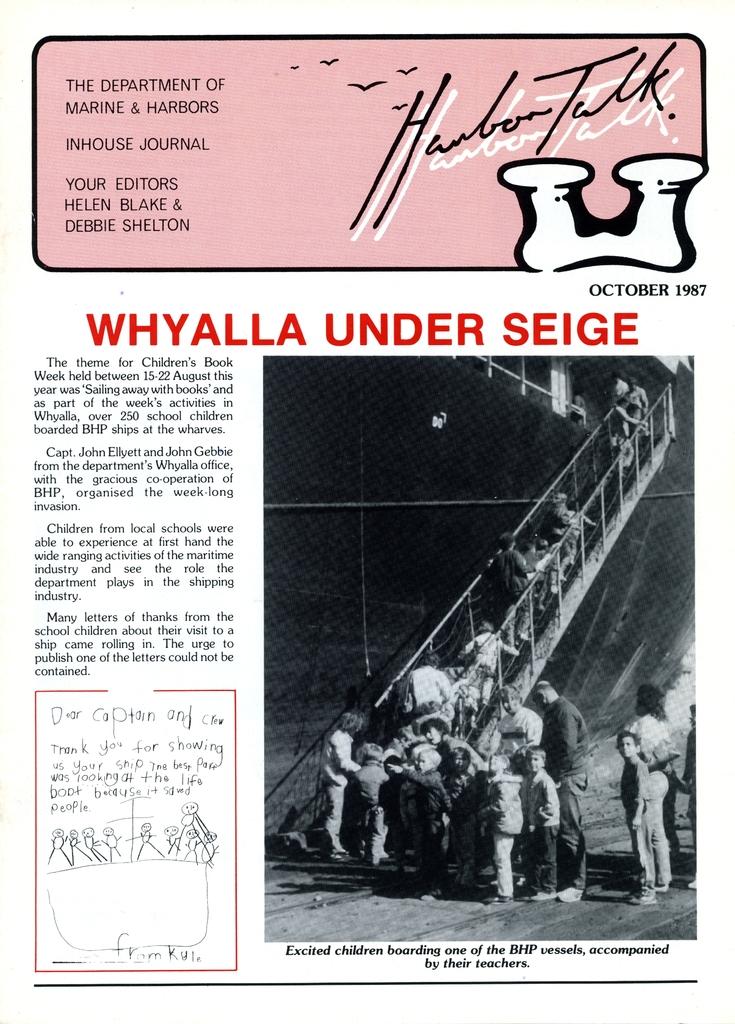What is under siege?
Give a very brief answer. Whyalla. In what year was this article written?
Make the answer very short. 1987. 